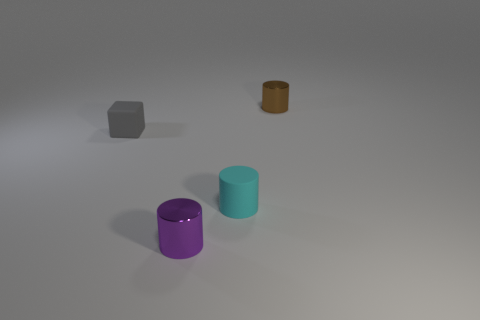There is a tiny cyan object that is in front of the tiny thing left of the small metallic cylinder that is to the left of the brown metal thing; what is its material?
Offer a terse response. Rubber. Is the material of the cyan object the same as the object that is to the left of the tiny purple cylinder?
Your answer should be compact. Yes. Is the number of small gray rubber things left of the cyan rubber object less than the number of small cylinders behind the purple shiny cylinder?
Your response must be concise. Yes. How many large brown spheres have the same material as the purple thing?
Offer a terse response. 0. Are there any purple metallic things that are on the right side of the tiny shiny cylinder in front of the metallic object behind the small gray thing?
Your response must be concise. No. How many cylinders are large green things or small cyan objects?
Your answer should be very brief. 1. There is a small cyan object; is its shape the same as the shiny object in front of the small gray matte cube?
Offer a terse response. Yes. Are there fewer things that are to the left of the matte cube than large blue metallic spheres?
Provide a succinct answer. No. Are there any rubber objects right of the small purple metal thing?
Give a very brief answer. Yes. Are there any small purple rubber things of the same shape as the small gray rubber thing?
Provide a succinct answer. No. 